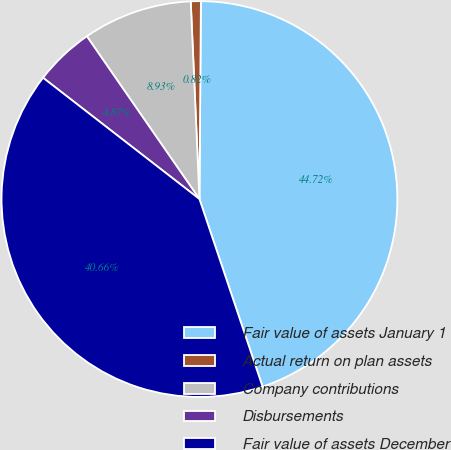Convert chart to OTSL. <chart><loc_0><loc_0><loc_500><loc_500><pie_chart><fcel>Fair value of assets January 1<fcel>Actual return on plan assets<fcel>Company contributions<fcel>Disbursements<fcel>Fair value of assets December<nl><fcel>44.72%<fcel>0.82%<fcel>8.93%<fcel>4.87%<fcel>40.66%<nl></chart> 